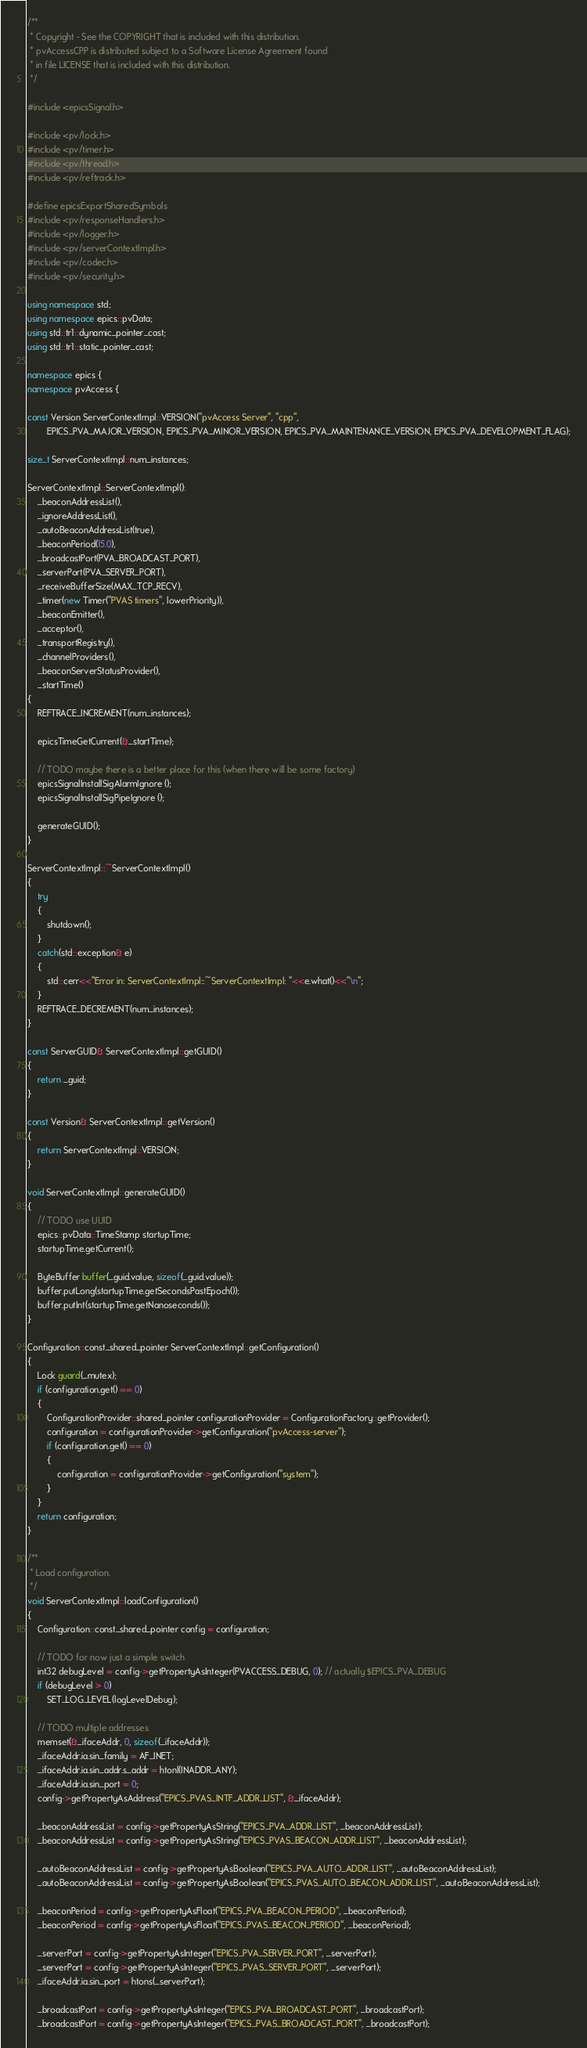<code> <loc_0><loc_0><loc_500><loc_500><_C++_>/**
 * Copyright - See the COPYRIGHT that is included with this distribution.
 * pvAccessCPP is distributed subject to a Software License Agreement found
 * in file LICENSE that is included with this distribution.
 */

#include <epicsSignal.h>

#include <pv/lock.h>
#include <pv/timer.h>
#include <pv/thread.h>
#include <pv/reftrack.h>

#define epicsExportSharedSymbols
#include <pv/responseHandlers.h>
#include <pv/logger.h>
#include <pv/serverContextImpl.h>
#include <pv/codec.h>
#include <pv/security.h>

using namespace std;
using namespace epics::pvData;
using std::tr1::dynamic_pointer_cast;
using std::tr1::static_pointer_cast;

namespace epics {
namespace pvAccess {

const Version ServerContextImpl::VERSION("pvAccess Server", "cpp",
        EPICS_PVA_MAJOR_VERSION, EPICS_PVA_MINOR_VERSION, EPICS_PVA_MAINTENANCE_VERSION, EPICS_PVA_DEVELOPMENT_FLAG);

size_t ServerContextImpl::num_instances;

ServerContextImpl::ServerContextImpl():
    _beaconAddressList(),
    _ignoreAddressList(),
    _autoBeaconAddressList(true),
    _beaconPeriod(15.0),
    _broadcastPort(PVA_BROADCAST_PORT),
    _serverPort(PVA_SERVER_PORT),
    _receiveBufferSize(MAX_TCP_RECV),
    _timer(new Timer("PVAS timers", lowerPriority)),
    _beaconEmitter(),
    _acceptor(),
    _transportRegistry(),
    _channelProviders(),
    _beaconServerStatusProvider(),
    _startTime()
{
    REFTRACE_INCREMENT(num_instances);

    epicsTimeGetCurrent(&_startTime);

    // TODO maybe there is a better place for this (when there will be some factory)
    epicsSignalInstallSigAlarmIgnore ();
    epicsSignalInstallSigPipeIgnore ();

    generateGUID();
}

ServerContextImpl::~ServerContextImpl()
{
    try
    {
        shutdown();
    }
    catch(std::exception& e)
    {
        std::cerr<<"Error in: ServerContextImpl::~ServerContextImpl: "<<e.what()<<"\n";
    }
    REFTRACE_DECREMENT(num_instances);
}

const ServerGUID& ServerContextImpl::getGUID()
{
    return _guid;
}

const Version& ServerContextImpl::getVersion()
{
    return ServerContextImpl::VERSION;
}

void ServerContextImpl::generateGUID()
{
    // TODO use UUID
    epics::pvData::TimeStamp startupTime;
    startupTime.getCurrent();

    ByteBuffer buffer(_guid.value, sizeof(_guid.value));
    buffer.putLong(startupTime.getSecondsPastEpoch());
    buffer.putInt(startupTime.getNanoseconds());
}

Configuration::const_shared_pointer ServerContextImpl::getConfiguration()
{
    Lock guard(_mutex);
    if (configuration.get() == 0)
    {
        ConfigurationProvider::shared_pointer configurationProvider = ConfigurationFactory::getProvider();
        configuration = configurationProvider->getConfiguration("pvAccess-server");
        if (configuration.get() == 0)
        {
            configuration = configurationProvider->getConfiguration("system");
        }
    }
    return configuration;
}

/**
 * Load configuration.
 */
void ServerContextImpl::loadConfiguration()
{
    Configuration::const_shared_pointer config = configuration;

    // TODO for now just a simple switch
    int32 debugLevel = config->getPropertyAsInteger(PVACCESS_DEBUG, 0); // actually $EPICS_PVA_DEBUG
    if (debugLevel > 0)
        SET_LOG_LEVEL(logLevelDebug);

    // TODO multiple addresses
    memset(&_ifaceAddr, 0, sizeof(_ifaceAddr));
    _ifaceAddr.ia.sin_family = AF_INET;
    _ifaceAddr.ia.sin_addr.s_addr = htonl(INADDR_ANY);
    _ifaceAddr.ia.sin_port = 0;
    config->getPropertyAsAddress("EPICS_PVAS_INTF_ADDR_LIST", &_ifaceAddr);

    _beaconAddressList = config->getPropertyAsString("EPICS_PVA_ADDR_LIST", _beaconAddressList);
    _beaconAddressList = config->getPropertyAsString("EPICS_PVAS_BEACON_ADDR_LIST", _beaconAddressList);

    _autoBeaconAddressList = config->getPropertyAsBoolean("EPICS_PVA_AUTO_ADDR_LIST", _autoBeaconAddressList);
    _autoBeaconAddressList = config->getPropertyAsBoolean("EPICS_PVAS_AUTO_BEACON_ADDR_LIST", _autoBeaconAddressList);

    _beaconPeriod = config->getPropertyAsFloat("EPICS_PVA_BEACON_PERIOD", _beaconPeriod);
    _beaconPeriod = config->getPropertyAsFloat("EPICS_PVAS_BEACON_PERIOD", _beaconPeriod);

    _serverPort = config->getPropertyAsInteger("EPICS_PVA_SERVER_PORT", _serverPort);
    _serverPort = config->getPropertyAsInteger("EPICS_PVAS_SERVER_PORT", _serverPort);
    _ifaceAddr.ia.sin_port = htons(_serverPort);

    _broadcastPort = config->getPropertyAsInteger("EPICS_PVA_BROADCAST_PORT", _broadcastPort);
    _broadcastPort = config->getPropertyAsInteger("EPICS_PVAS_BROADCAST_PORT", _broadcastPort);
</code> 